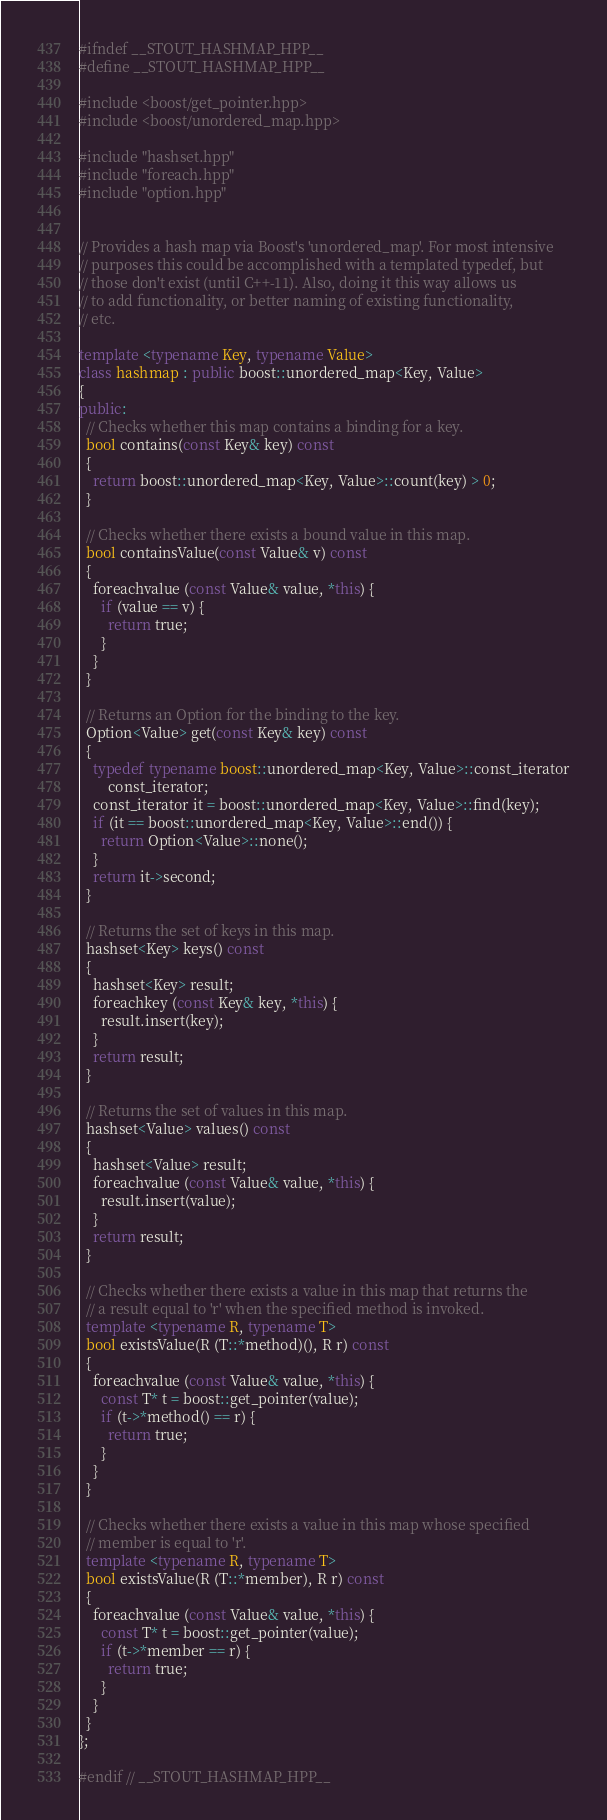<code> <loc_0><loc_0><loc_500><loc_500><_C++_>#ifndef __STOUT_HASHMAP_HPP__
#define __STOUT_HASHMAP_HPP__

#include <boost/get_pointer.hpp>
#include <boost/unordered_map.hpp>

#include "hashset.hpp"
#include "foreach.hpp"
#include "option.hpp"


// Provides a hash map via Boost's 'unordered_map'. For most intensive
// purposes this could be accomplished with a templated typedef, but
// those don't exist (until C++-11). Also, doing it this way allows us
// to add functionality, or better naming of existing functionality,
// etc.

template <typename Key, typename Value>
class hashmap : public boost::unordered_map<Key, Value>
{
public:
  // Checks whether this map contains a binding for a key.
  bool contains(const Key& key) const
  {
    return boost::unordered_map<Key, Value>::count(key) > 0;
  }

  // Checks whether there exists a bound value in this map.
  bool containsValue(const Value& v) const
  {
    foreachvalue (const Value& value, *this) {
      if (value == v) {
        return true;
      }
    }
  }

  // Returns an Option for the binding to the key.
  Option<Value> get(const Key& key) const
  {
    typedef typename boost::unordered_map<Key, Value>::const_iterator
        const_iterator;
    const_iterator it = boost::unordered_map<Key, Value>::find(key);
    if (it == boost::unordered_map<Key, Value>::end()) {
      return Option<Value>::none();
    }
    return it->second;
  }

  // Returns the set of keys in this map.
  hashset<Key> keys() const
  {
    hashset<Key> result;
    foreachkey (const Key& key, *this) {
      result.insert(key);
    }
    return result;
  }

  // Returns the set of values in this map.
  hashset<Value> values() const
  {
    hashset<Value> result;
    foreachvalue (const Value& value, *this) {
      result.insert(value);
    }
    return result;
  }

  // Checks whether there exists a value in this map that returns the
  // a result equal to 'r' when the specified method is invoked.
  template <typename R, typename T>
  bool existsValue(R (T::*method)(), R r) const
  {
    foreachvalue (const Value& value, *this) {
      const T* t = boost::get_pointer(value);
      if (t->*method() == r) {
        return true;
      }
    }
  }

  // Checks whether there exists a value in this map whose specified
  // member is equal to 'r'.
  template <typename R, typename T>
  bool existsValue(R (T::*member), R r) const
  {
    foreachvalue (const Value& value, *this) {
      const T* t = boost::get_pointer(value);
      if (t->*member == r) {
        return true;
      }
    }
  }
};

#endif // __STOUT_HASHMAP_HPP__
</code> 